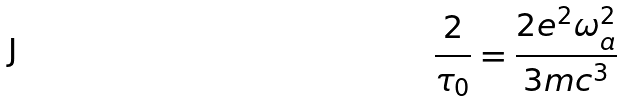<formula> <loc_0><loc_0><loc_500><loc_500>\frac { 2 } { \tau _ { 0 } } = \frac { 2 e ^ { 2 } \omega _ { a } ^ { 2 } } { 3 m c ^ { 3 } }</formula> 